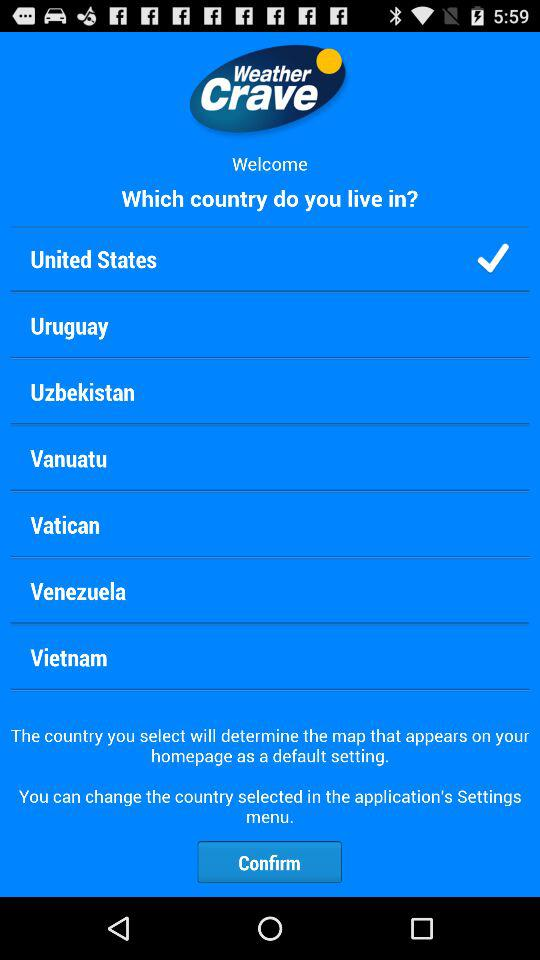Which option is checked? The checked option is the United States. 